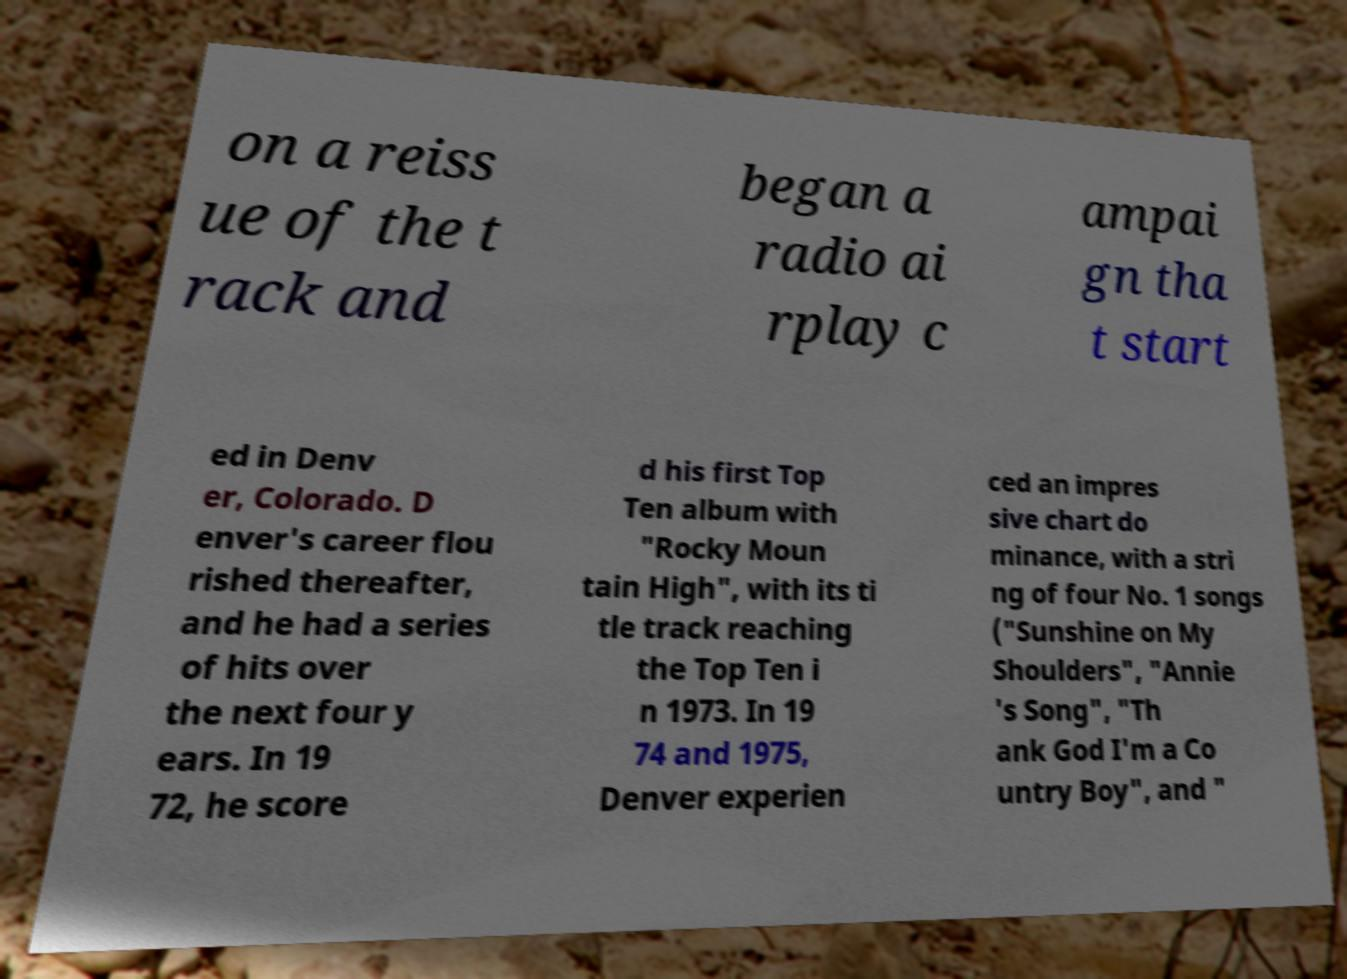Can you read and provide the text displayed in the image?This photo seems to have some interesting text. Can you extract and type it out for me? on a reiss ue of the t rack and began a radio ai rplay c ampai gn tha t start ed in Denv er, Colorado. D enver's career flou rished thereafter, and he had a series of hits over the next four y ears. In 19 72, he score d his first Top Ten album with "Rocky Moun tain High", with its ti tle track reaching the Top Ten i n 1973. In 19 74 and 1975, Denver experien ced an impres sive chart do minance, with a stri ng of four No. 1 songs ("Sunshine on My Shoulders", "Annie 's Song", "Th ank God I'm a Co untry Boy", and " 